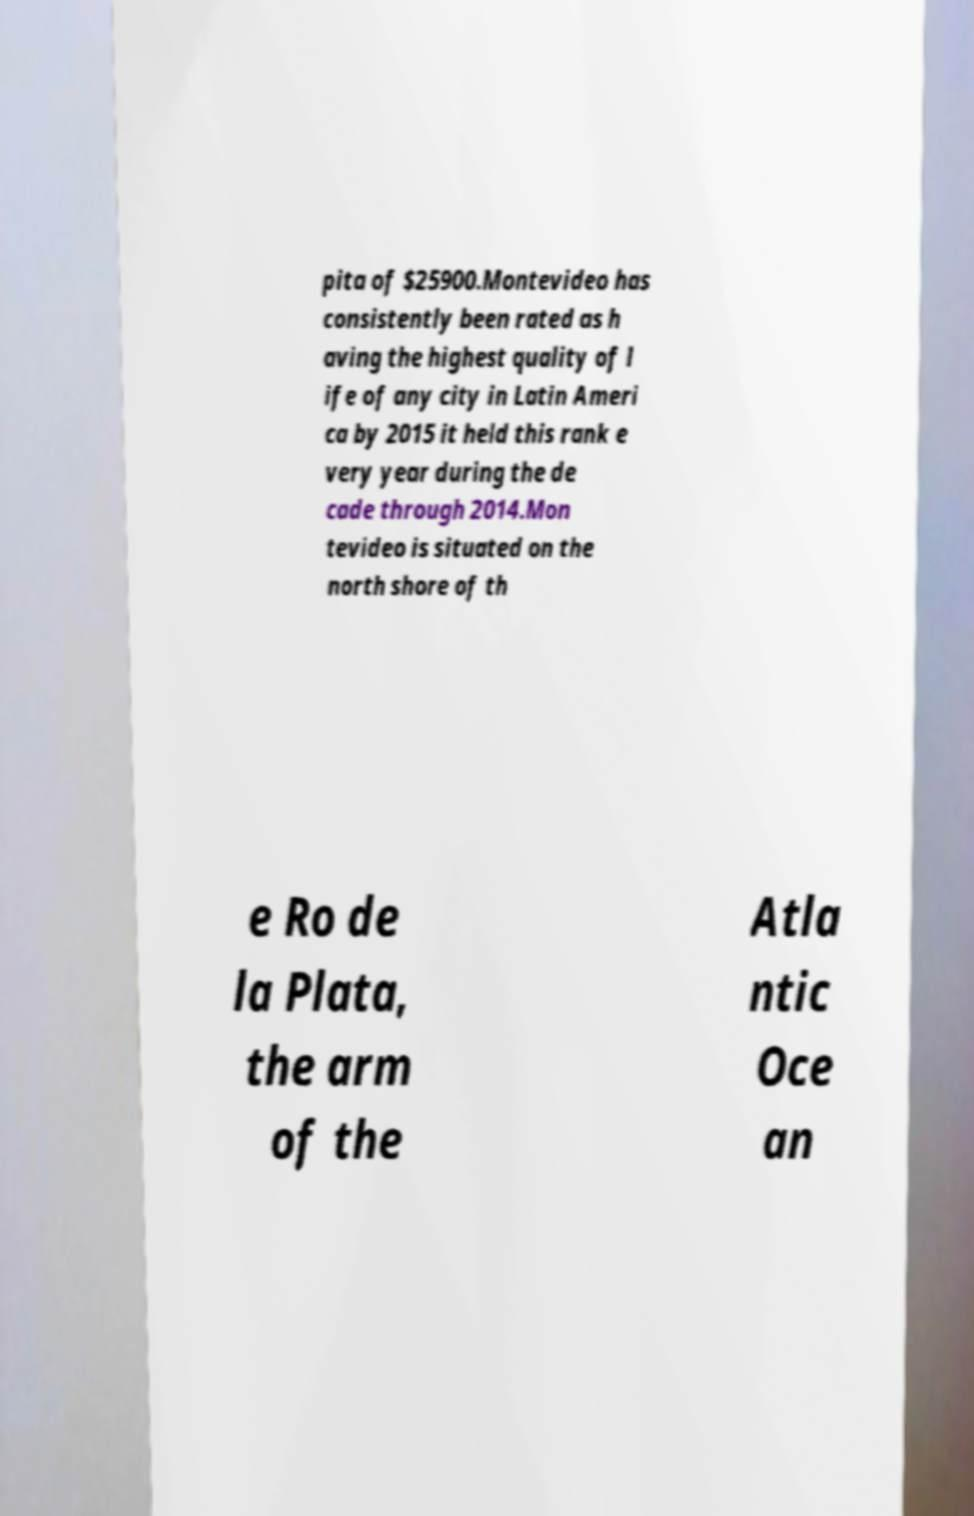What messages or text are displayed in this image? I need them in a readable, typed format. pita of $25900.Montevideo has consistently been rated as h aving the highest quality of l ife of any city in Latin Ameri ca by 2015 it held this rank e very year during the de cade through 2014.Mon tevideo is situated on the north shore of th e Ro de la Plata, the arm of the Atla ntic Oce an 